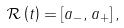<formula> <loc_0><loc_0><loc_500><loc_500>\mathcal { R } \left ( t \right ) = \left [ a _ { - } , a _ { + } \right ] ,</formula> 